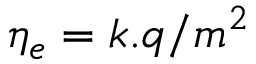Convert formula to latex. <formula><loc_0><loc_0><loc_500><loc_500>\eta _ { e } = k . q / m ^ { 2 }</formula> 